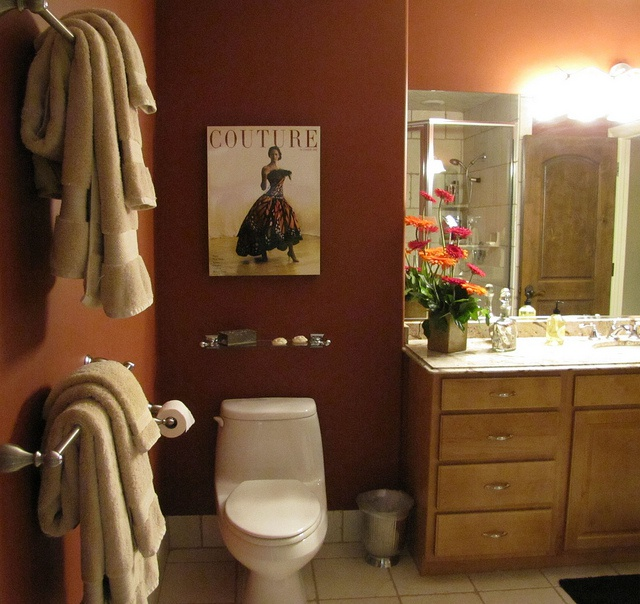Describe the objects in this image and their specific colors. I can see toilet in black, tan, gray, and brown tones, potted plant in black, tan, olive, and gray tones, bottle in black, tan, and ivory tones, vase in black, tan, and olive tones, and bottle in black, khaki, beige, and olive tones in this image. 